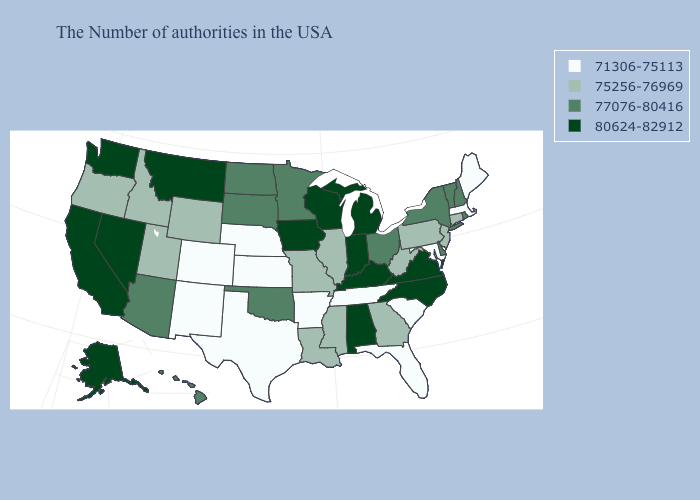What is the value of Iowa?
Keep it brief. 80624-82912. How many symbols are there in the legend?
Quick response, please. 4. Does Texas have the lowest value in the South?
Be succinct. Yes. Name the states that have a value in the range 75256-76969?
Write a very short answer. Connecticut, New Jersey, Pennsylvania, West Virginia, Georgia, Illinois, Mississippi, Louisiana, Missouri, Wyoming, Utah, Idaho, Oregon. Among the states that border Delaware , does Maryland have the highest value?
Answer briefly. No. Is the legend a continuous bar?
Give a very brief answer. No. Name the states that have a value in the range 75256-76969?
Concise answer only. Connecticut, New Jersey, Pennsylvania, West Virginia, Georgia, Illinois, Mississippi, Louisiana, Missouri, Wyoming, Utah, Idaho, Oregon. Does Oklahoma have a higher value than Wisconsin?
Give a very brief answer. No. Which states hav the highest value in the South?
Concise answer only. Virginia, North Carolina, Kentucky, Alabama. What is the value of Alabama?
Write a very short answer. 80624-82912. What is the highest value in the Northeast ?
Concise answer only. 77076-80416. Which states have the lowest value in the USA?
Short answer required. Maine, Massachusetts, Maryland, South Carolina, Florida, Tennessee, Arkansas, Kansas, Nebraska, Texas, Colorado, New Mexico. Which states have the lowest value in the Northeast?
Concise answer only. Maine, Massachusetts. Name the states that have a value in the range 75256-76969?
Write a very short answer. Connecticut, New Jersey, Pennsylvania, West Virginia, Georgia, Illinois, Mississippi, Louisiana, Missouri, Wyoming, Utah, Idaho, Oregon. What is the value of Minnesota?
Keep it brief. 77076-80416. 